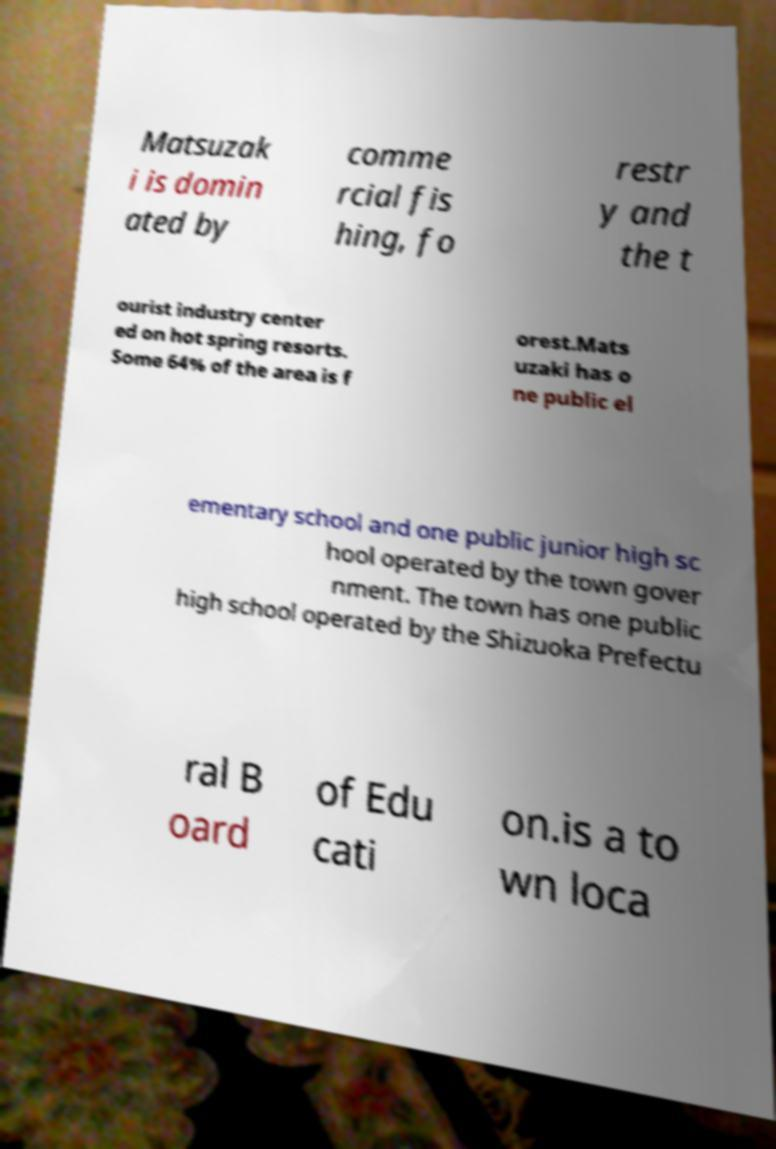There's text embedded in this image that I need extracted. Can you transcribe it verbatim? Matsuzak i is domin ated by comme rcial fis hing, fo restr y and the t ourist industry center ed on hot spring resorts. Some 64% of the area is f orest.Mats uzaki has o ne public el ementary school and one public junior high sc hool operated by the town gover nment. The town has one public high school operated by the Shizuoka Prefectu ral B oard of Edu cati on.is a to wn loca 